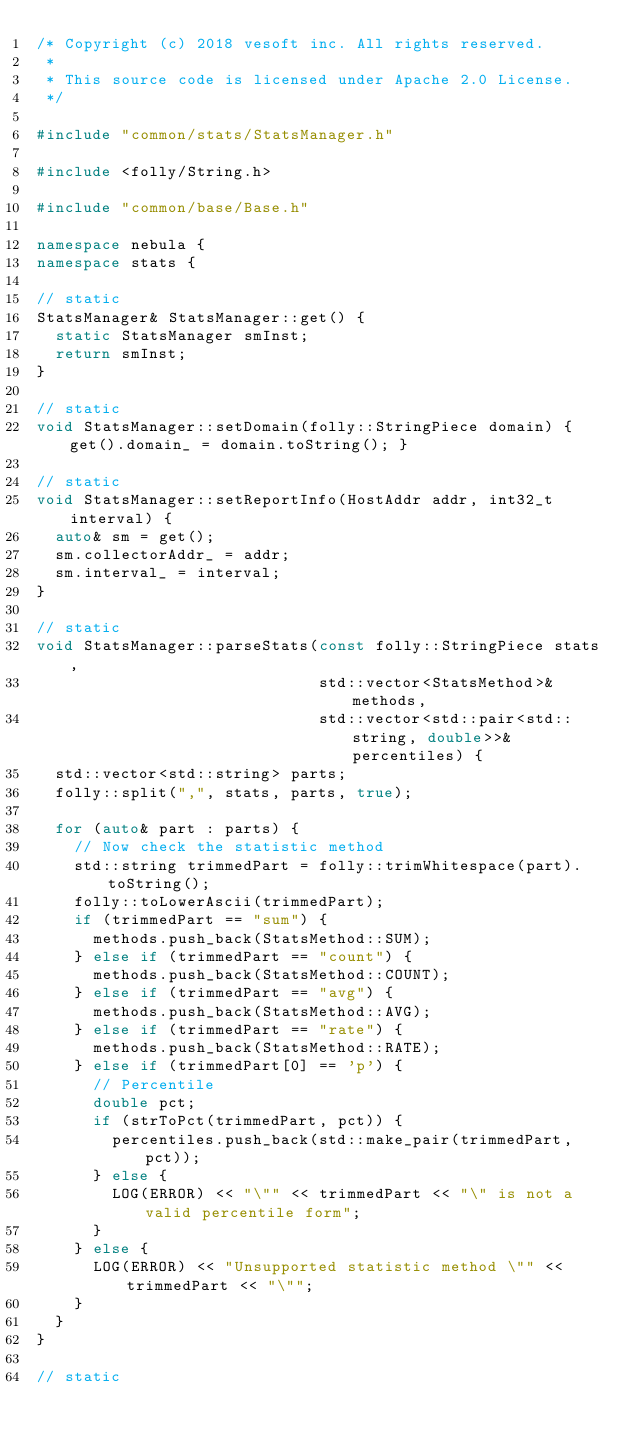Convert code to text. <code><loc_0><loc_0><loc_500><loc_500><_C++_>/* Copyright (c) 2018 vesoft inc. All rights reserved.
 *
 * This source code is licensed under Apache 2.0 License.
 */

#include "common/stats/StatsManager.h"

#include <folly/String.h>

#include "common/base/Base.h"

namespace nebula {
namespace stats {

// static
StatsManager& StatsManager::get() {
  static StatsManager smInst;
  return smInst;
}

// static
void StatsManager::setDomain(folly::StringPiece domain) { get().domain_ = domain.toString(); }

// static
void StatsManager::setReportInfo(HostAddr addr, int32_t interval) {
  auto& sm = get();
  sm.collectorAddr_ = addr;
  sm.interval_ = interval;
}

// static
void StatsManager::parseStats(const folly::StringPiece stats,
                              std::vector<StatsMethod>& methods,
                              std::vector<std::pair<std::string, double>>& percentiles) {
  std::vector<std::string> parts;
  folly::split(",", stats, parts, true);

  for (auto& part : parts) {
    // Now check the statistic method
    std::string trimmedPart = folly::trimWhitespace(part).toString();
    folly::toLowerAscii(trimmedPart);
    if (trimmedPart == "sum") {
      methods.push_back(StatsMethod::SUM);
    } else if (trimmedPart == "count") {
      methods.push_back(StatsMethod::COUNT);
    } else if (trimmedPart == "avg") {
      methods.push_back(StatsMethod::AVG);
    } else if (trimmedPart == "rate") {
      methods.push_back(StatsMethod::RATE);
    } else if (trimmedPart[0] == 'p') {
      // Percentile
      double pct;
      if (strToPct(trimmedPart, pct)) {
        percentiles.push_back(std::make_pair(trimmedPart, pct));
      } else {
        LOG(ERROR) << "\"" << trimmedPart << "\" is not a valid percentile form";
      }
    } else {
      LOG(ERROR) << "Unsupported statistic method \"" << trimmedPart << "\"";
    }
  }
}

// static</code> 